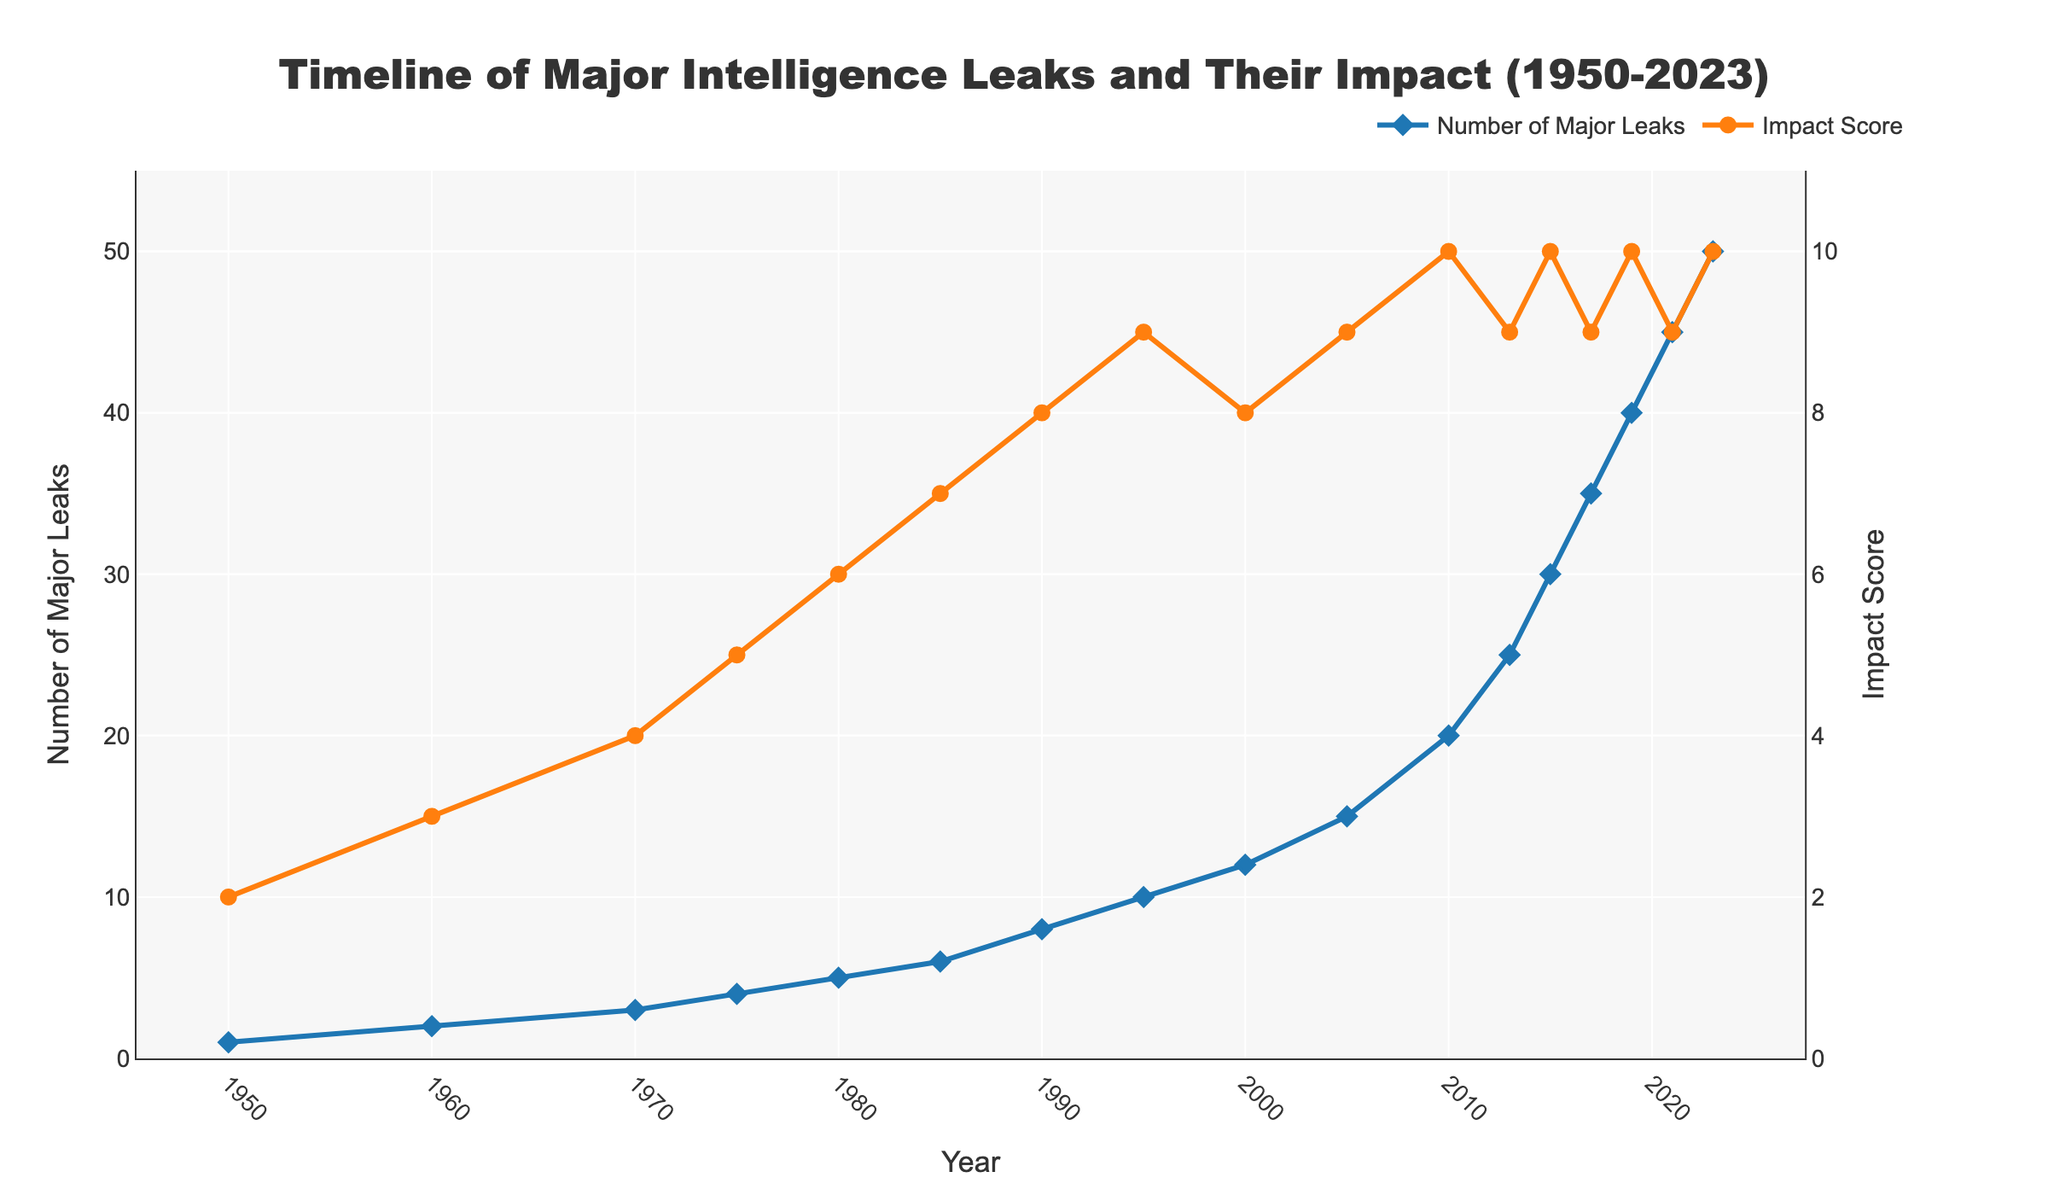What is the overall trend in the number of major intelligence leaks from 1950 to 2023? The overall trend shows a continuous increase in the number of major intelligence leaks. Starting from 1 in 1950, it rises steadily through the years, culminating at 50 in 2023.
Answer: The number of leaks increases continuously During which period did the number of major leaks increase the most rapidly? The period with the most rapid increase appears to be between 2013 and 2019. The number of leaks jumps from 25 to 40, a rise of 15 in just 6 years.
Answer: 2013 to 2019 Compare the impact score in 2010 and 2013. What can you observe? The impact score in 2010 is 10, and it remained at 9 in 2013. This indicates a short-term decrease immediately after the peak in 2010.
Answer: The impact score decreases from 2010 to 2013 How many years saw the impact score reach its highest value? The highest impact score is 10, which was achieved in the years 2010, 2015, 2019, and 2023.
Answer: 4 years What is the average impact score from 2000 to 2023? The impact scores from 2000 to 2023 are 8, 9, 10, 9, 10, 9, 10, and 10. Adding these gives 75, and there are 8 scores. 75/8 = 9.375
Answer: 9.375 Which year had the lowest impact score after 1970? The lowest impact score after 1970 is 6, observed in the year 1980.
Answer: 1980 Compare the rate of change in the number of leaks between 1950 and 1975 and the rate of change between 2000 and 2023. Which period experienced a higher rate of change? The rate of change from 1950 to 1975 is (4-1)/(1975-1950) = 3/25 = 0.12. From 2000 to 2023, (50-12)/(2023-2000) = 38/23 ≈ 1.65. The rate of change is higher in the latter period.
Answer: 2000 to 2023 By what percentage did the number of major leaks increase between 2000 and 2010? The number of leaks increased from 12 in 2000 to 20 in 2010. Percentage increase = ((20 - 12) / 12) * 100 = 66.67%.
Answer: 66.67% Describe the visual representation of the trends in the impact scores and number of major leaks. The number of major leaks is represented by a blue diamond marker line, gradually increasing and peaking at 50 in 2023. The impact score, shown in an orange circle marker line, fluctuates less but peaks multiple times at 10.
Answer: Blue line for leaks, Orange line for impact 